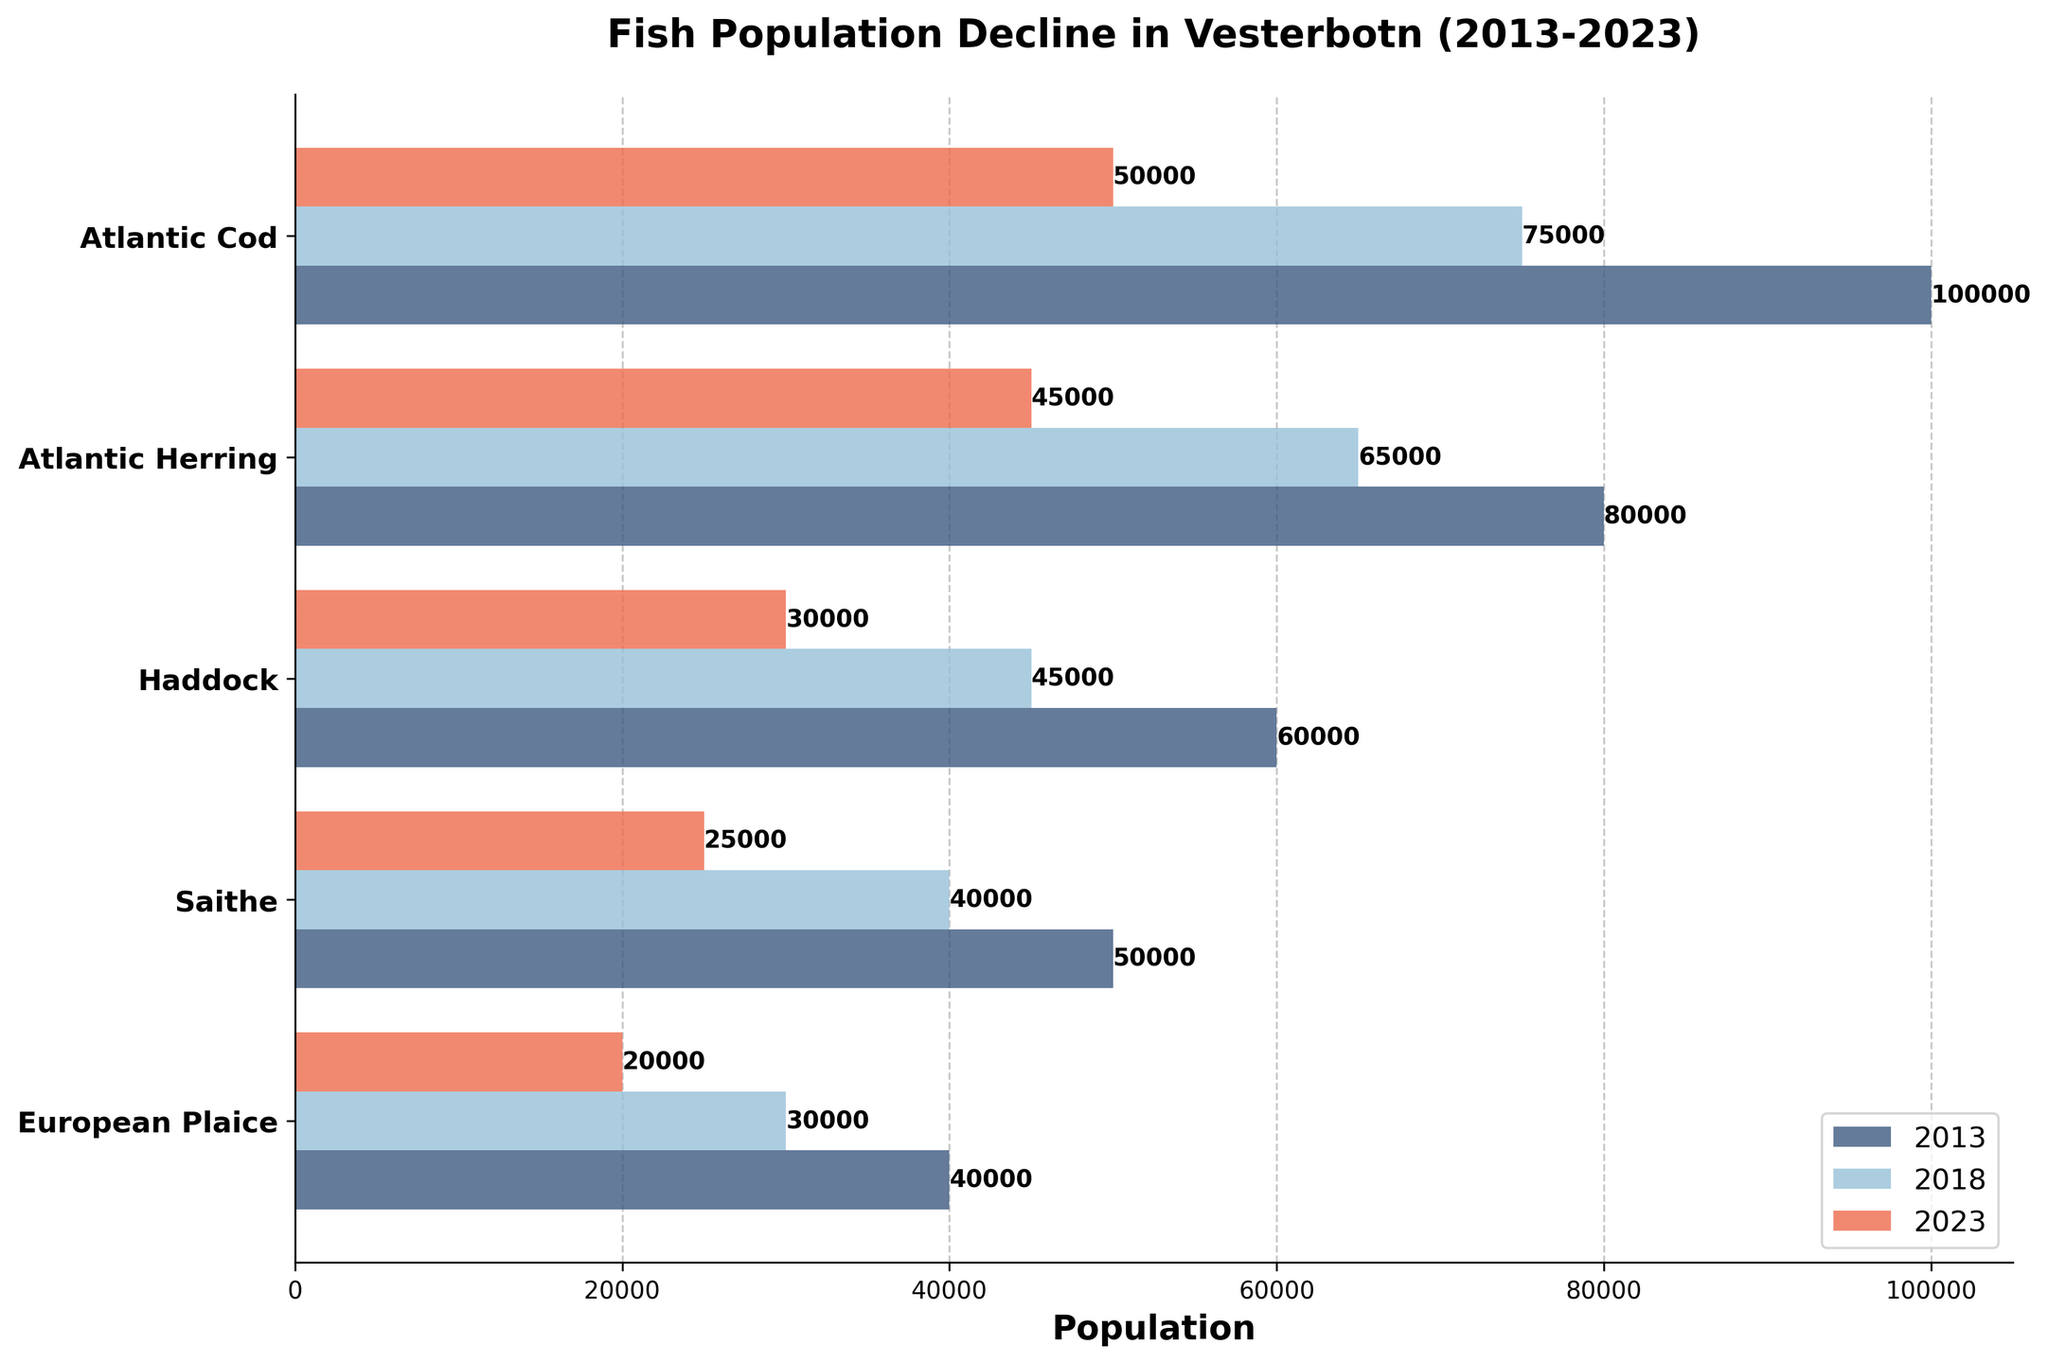What is the title of the chart? The title of the chart is displayed at the top of the figure. It typically summarizes the main topic of the visualization.
Answer: Fish Population Decline in Vesterbotn (2013-2023) How many fish species are represented in the chart? Count the number of unique labels on the y-axis to determine the number of fish species represented.
Answer: 5 What is the color associated with the 2023 population? Identify the color used in the bar representing the 2023 population in the chart's legend.
Answer: Red How much did the Atlantic Cod population decline from 2013 to 2023? Subtract the 2023 population value from the 2013 population value for the Atlantic Cod species.
Answer: 50000 Which fish species had the smallest population in 2023? Compare the heights of the bars for the 2023 population across all species and identify the shortest one.
Answer: European Plaice What is the total fish population in 2013 across all species? Add the 2013 population values of all the fish species.
Answer: 340000 Which fish species saw the least decline in population from 2018 to 2023? Calculate the population decline for each species between 2018 and 2023, then identify the smallest decline.
Answer: Saithe What is the average population of Atlantic Herring over the three years? Calculate the average population by summing the population values for Atlantic Herring across the three years and dividing by three.
Answer: 63333 Which species had a consistent 20000 decline in population each 5-year period? Identify the species whose population dropped by exactly 20000 in each 5-year interval (2013-2018 and 2018-2023).
Answer: Saithe Is the population decline of Haddock higher than that of European Plaice from 2013 to 2023? Compare the total population decline of Haddock and European Plaice from 2013 to 2023 by subtracting 2023 populations from 2013 populations and then comparing.
Answer: Yes 